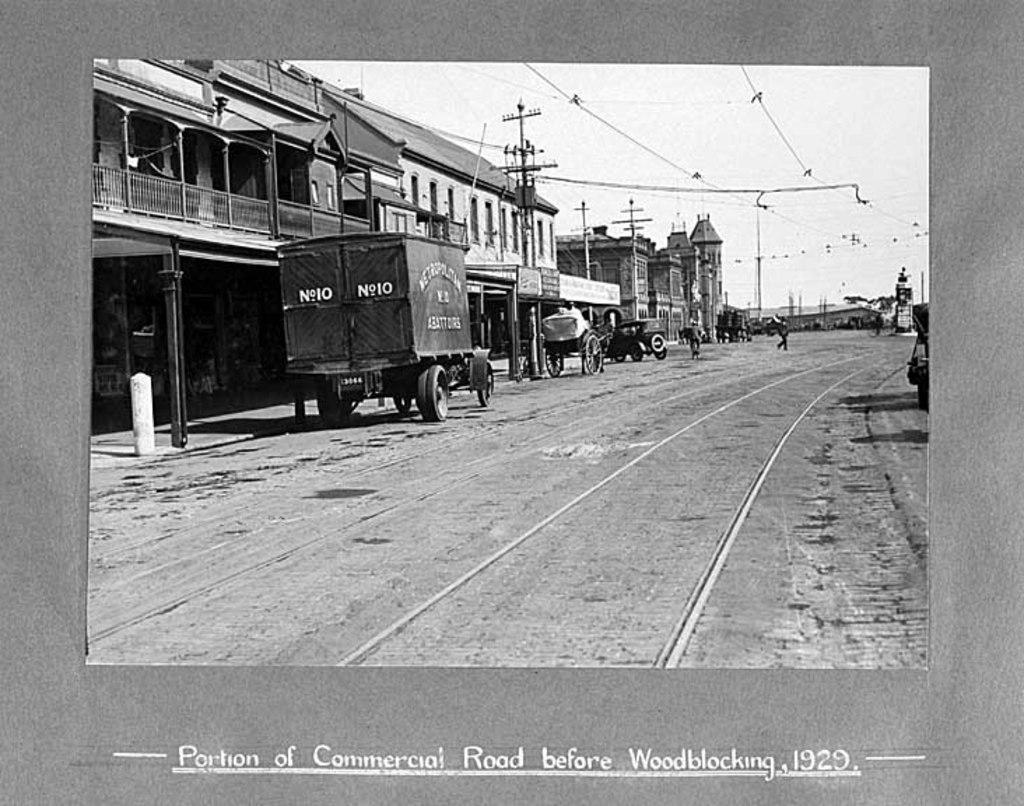Can you describe this image briefly? In this picture there is a track and there are few vehicles on the road and there are few wires above it and there are buildings in the left corner and there is something written below the image. 